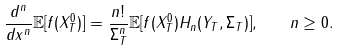Convert formula to latex. <formula><loc_0><loc_0><loc_500><loc_500>\frac { d ^ { n } } { d x ^ { n } } \mathbb { E } [ f ( X _ { T } ^ { 0 } ) ] = \frac { n ! } { \Sigma _ { T } ^ { n } } \mathbb { E } [ f ( X _ { T } ^ { 0 } ) H _ { n } ( Y _ { T } , \Sigma _ { T } ) ] , \quad n \geq 0 .</formula> 